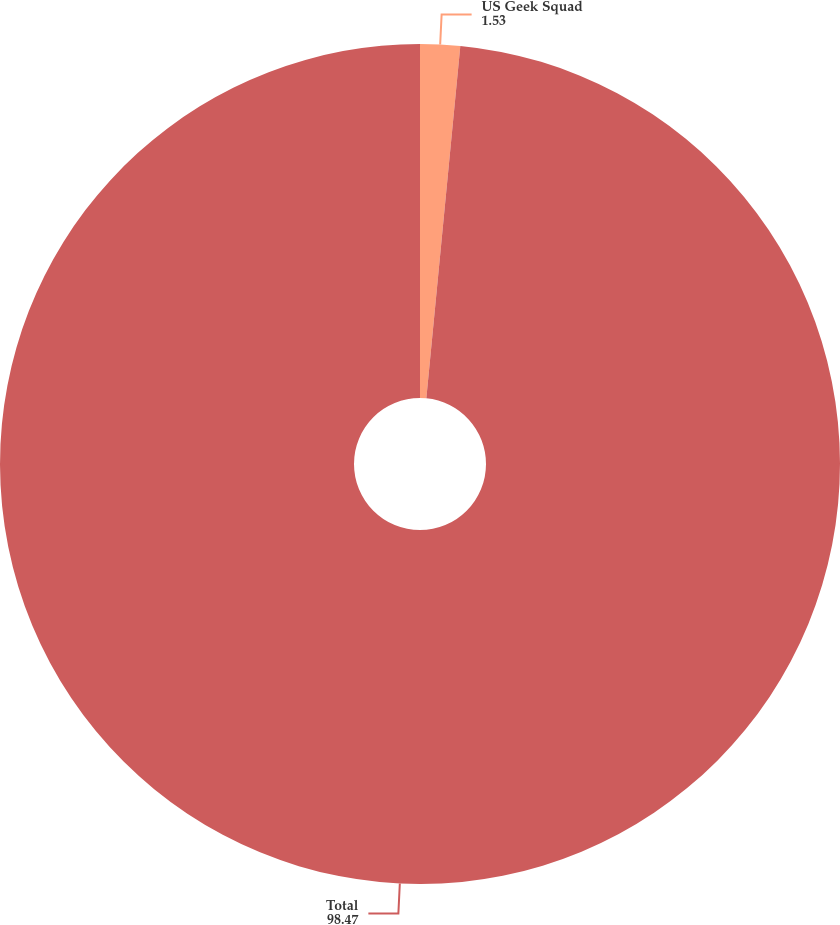Convert chart to OTSL. <chart><loc_0><loc_0><loc_500><loc_500><pie_chart><fcel>US Geek Squad<fcel>Total<nl><fcel>1.53%<fcel>98.47%<nl></chart> 